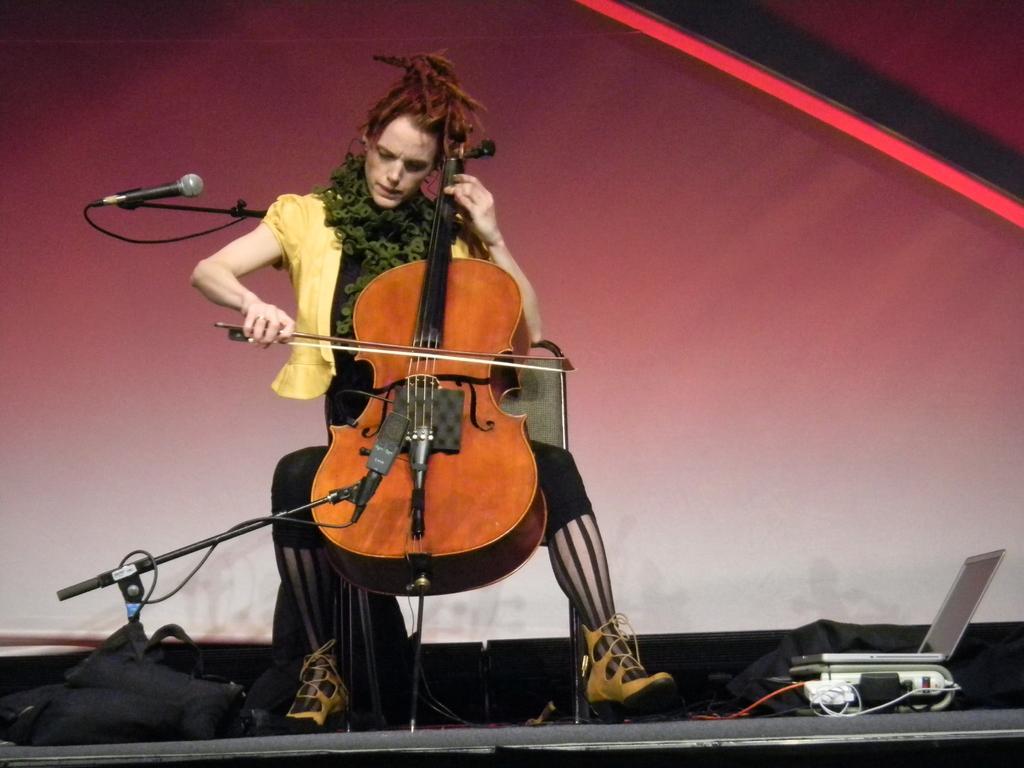How would you summarize this image in a sentence or two? This image consists of a woman playing violin. She is wearing a yellow dress. There are two mic along with mic stands. At the bottom, there is a dais. To the right, there is a laptop. In the background, there is a banner. 